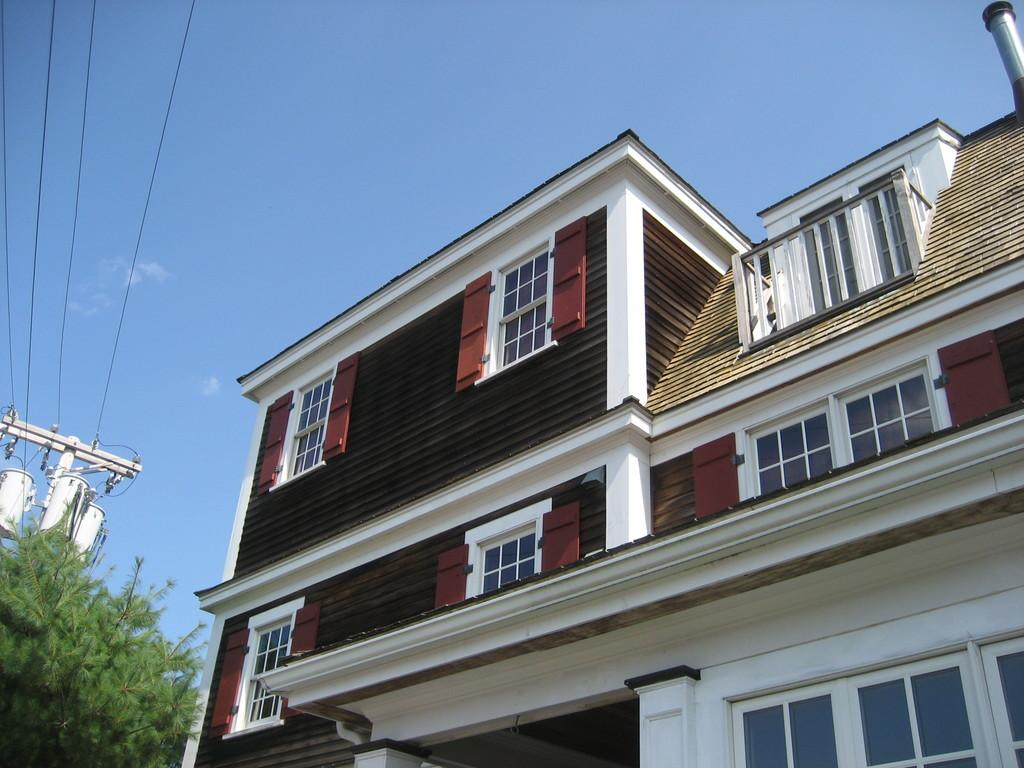What type of structure is visible in the image? There is a building in the image. What other natural elements can be seen in the image? There are trees in the image. What architectural features are present on the building? There are windows in the image. What additional man-made objects can be seen in the image? There are wires and an electric pole in the image. What is visible in the background of the image? The sky is visible in the background of the image, and clouds are present in the sky. What type of string is being used to hold up the clouds in the image? There is no string present in the image; the clouds are naturally suspended in the sky. 